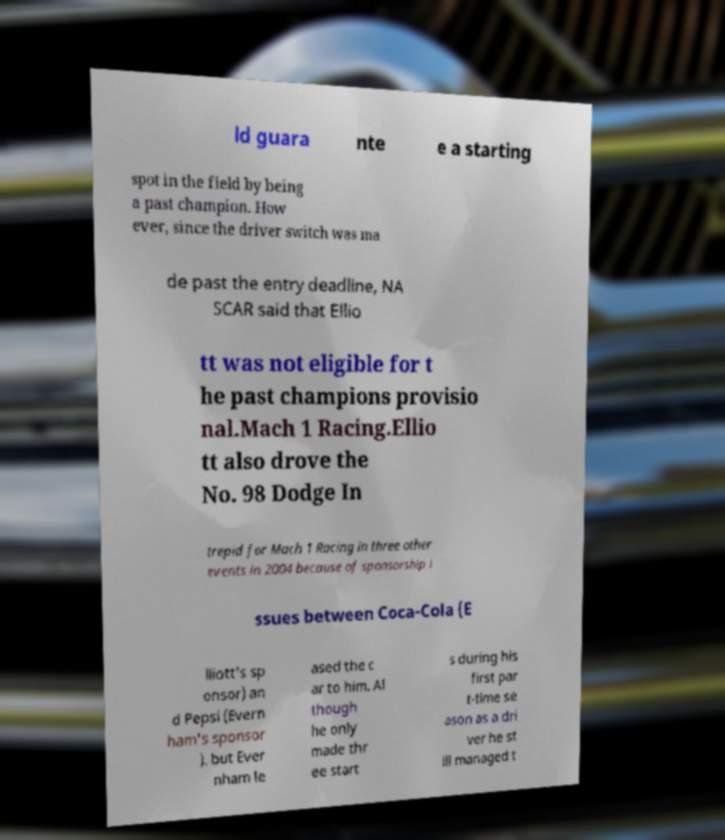Can you accurately transcribe the text from the provided image for me? ld guara nte e a starting spot in the field by being a past champion. How ever, since the driver switch was ma de past the entry deadline, NA SCAR said that Ellio tt was not eligible for t he past champions provisio nal.Mach 1 Racing.Ellio tt also drove the No. 98 Dodge In trepid for Mach 1 Racing in three other events in 2004 because of sponsorship i ssues between Coca-Cola (E lliott's sp onsor) an d Pepsi (Evern ham's sponsor ). but Ever nham le ased the c ar to him. Al though he only made thr ee start s during his first par t-time se ason as a dri ver he st ill managed t 